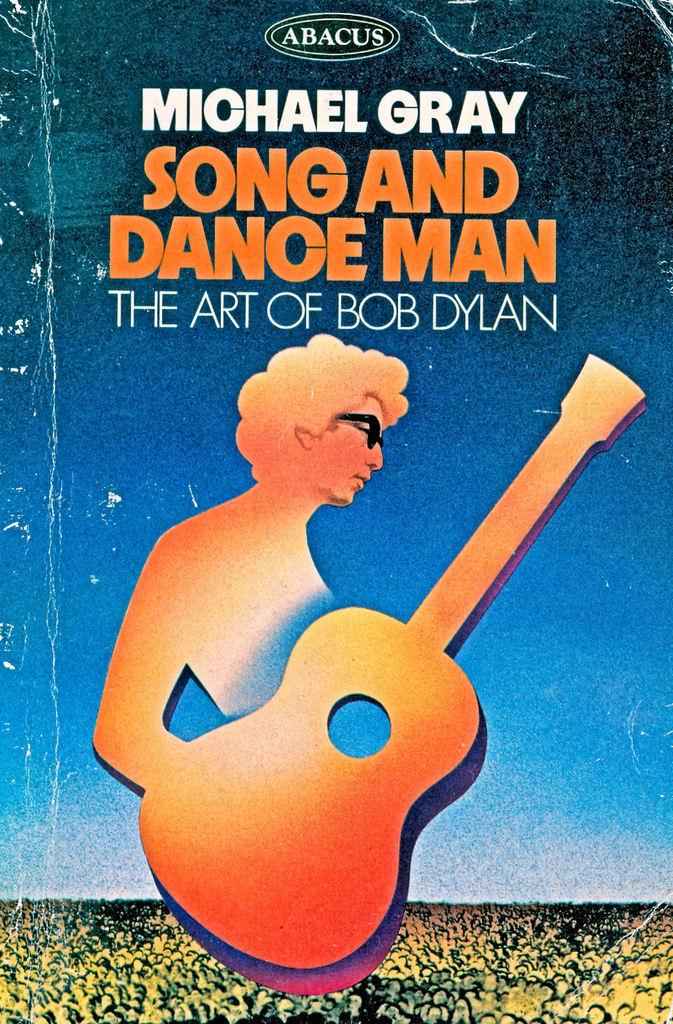<image>
Give a short and clear explanation of the subsequent image. The Art of Bob Dylan paperback has a crinkle on the top corner of the cover. 